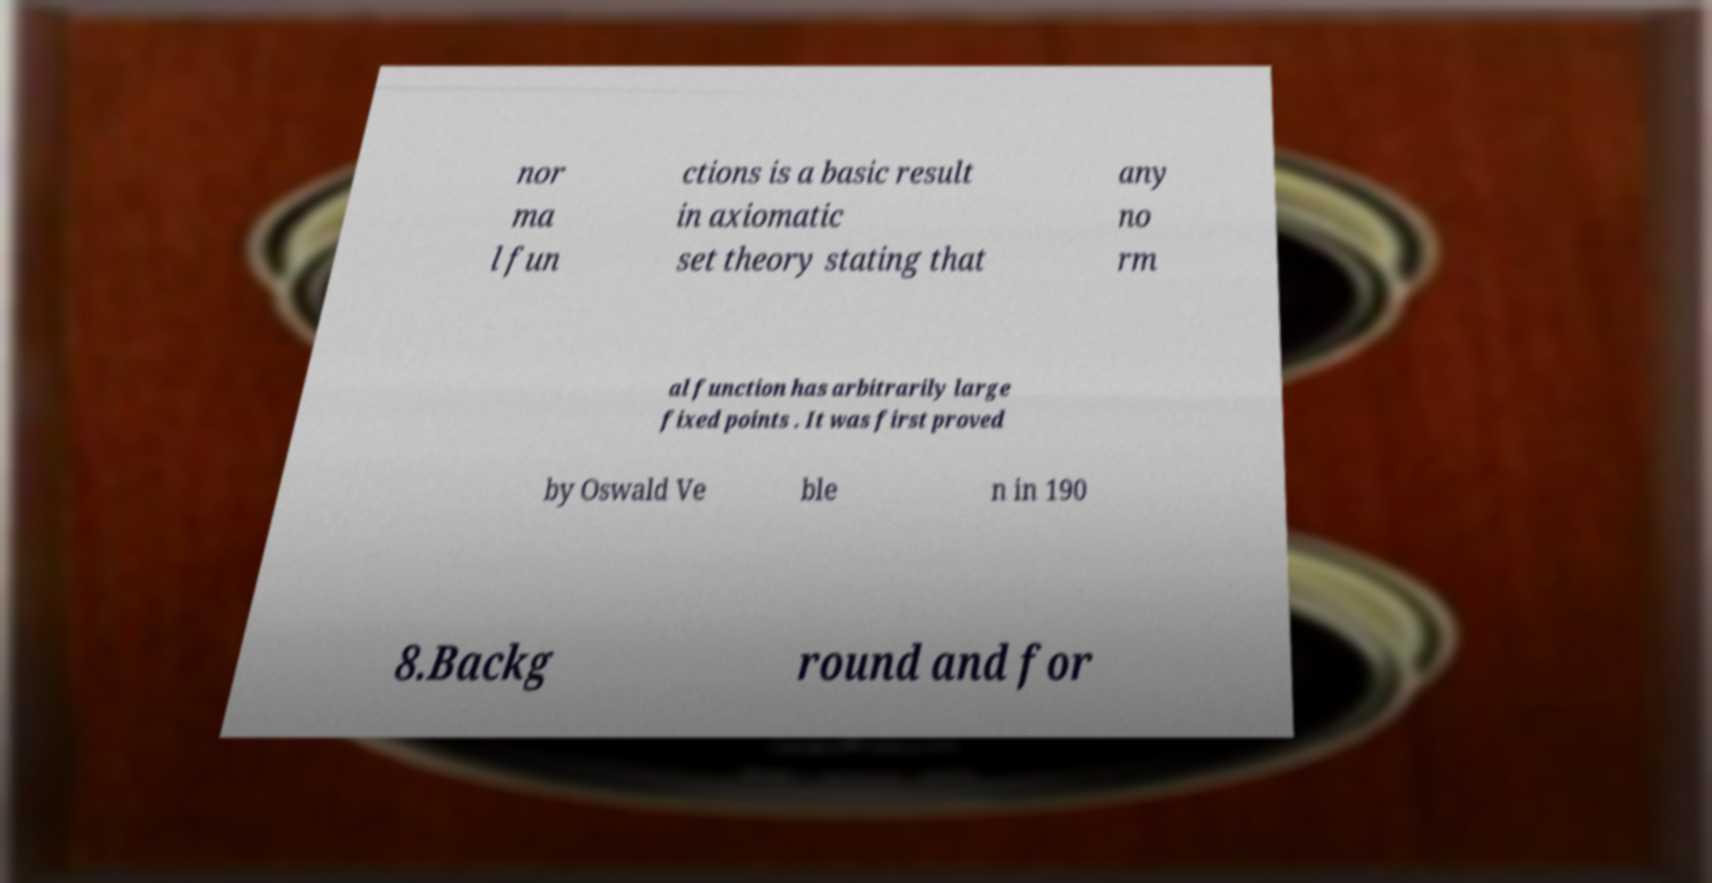Please identify and transcribe the text found in this image. nor ma l fun ctions is a basic result in axiomatic set theory stating that any no rm al function has arbitrarily large fixed points . It was first proved by Oswald Ve ble n in 190 8.Backg round and for 